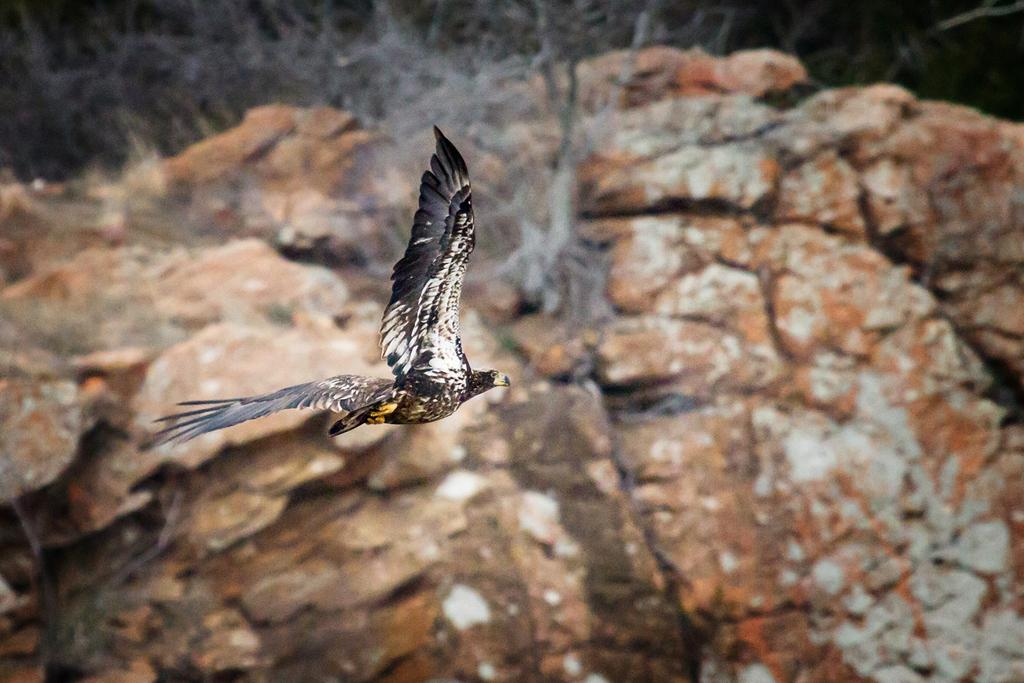What type of animal can be seen in the image? There is a bird in the image. What is the bird doing in the image? The bird is flying in the air. What can be seen in the background of the image? There are rocks visible in the background of the image. How would you describe the background of the image? The background of the image is blurred. What type of knife is the bird using to cut the powder in the image? There is no knife or powder present in the image; it features a bird flying in the air with rocks in the background. 